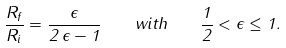<formula> <loc_0><loc_0><loc_500><loc_500>\frac { R _ { f } } { R _ { i } } = \frac { \epsilon } { 2 \, \epsilon - 1 } \quad w i t h \quad \frac { 1 } { 2 } < \epsilon \leq 1 .</formula> 